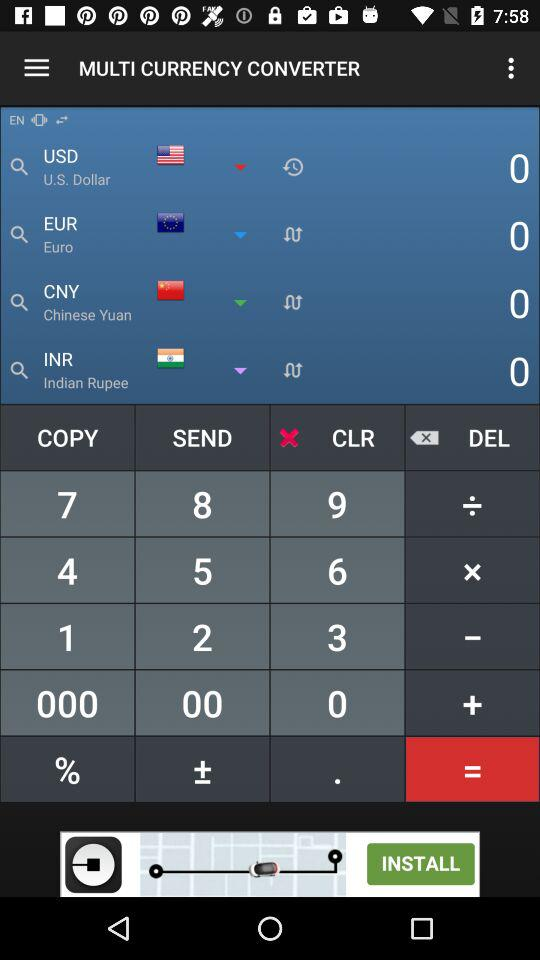What is the application name? The application name is "MULTI CURRENCY CONVERTER". 